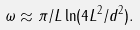<formula> <loc_0><loc_0><loc_500><loc_500>\omega \approx \pi / L \ln ( 4 L ^ { 2 } / d ^ { 2 } ) .</formula> 